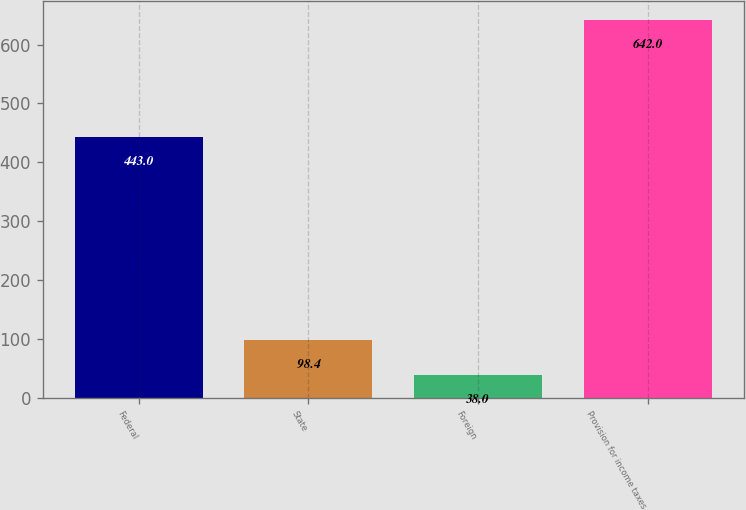Convert chart to OTSL. <chart><loc_0><loc_0><loc_500><loc_500><bar_chart><fcel>Federal<fcel>State<fcel>Foreign<fcel>Provision for income taxes<nl><fcel>443<fcel>98.4<fcel>38<fcel>642<nl></chart> 